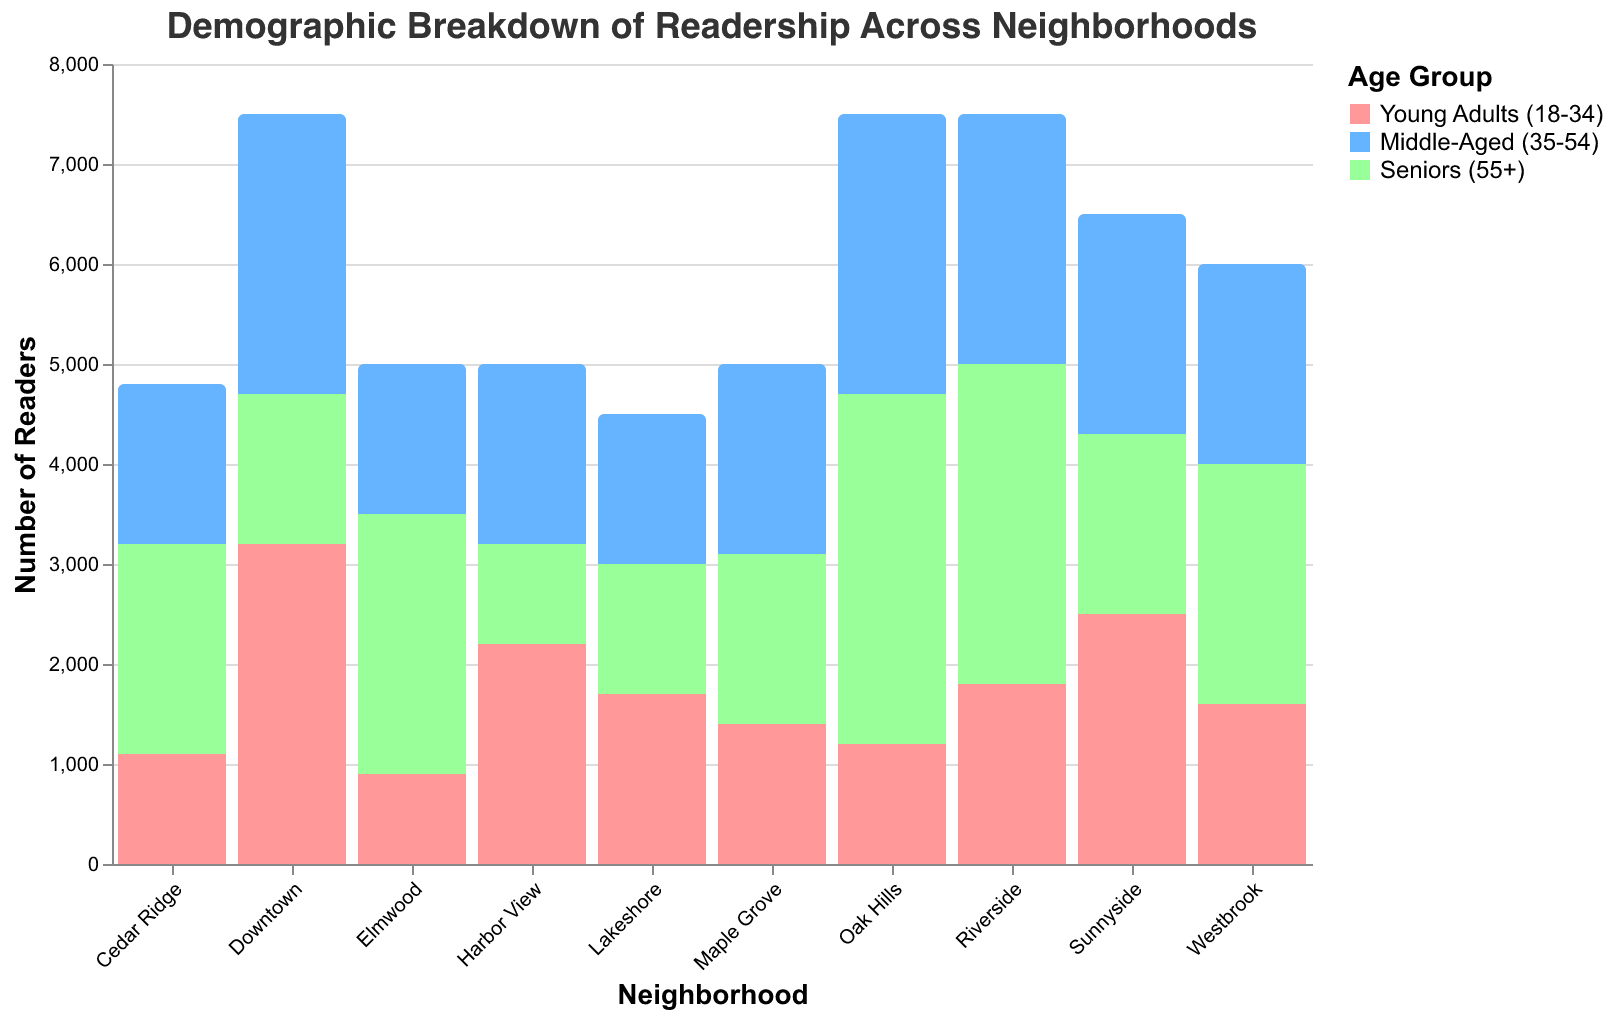Which neighborhood has the highest total readership? According to the figure, the neighborhood with the highest bar for total readership would indicate the highest number. Downtown has the tallest bar at 7500 readers.
Answer: Downtown Which age group has the most readers in Oak Hills? In Oak Hills, the age group with the highest bar in the corresponding section of the chart is Seniors (55+), with a value of 3500.
Answer: Seniors (55+) Compare the number of middle-aged readers (35-54) in Downtown and Riverside. Which neighborhood has more? By examining the respective bars for middle-aged readers (35-54) in Downtown and Riverside, we see that Downtown has 2800, while Riverside has 2500. Therefore, Downtown has more.
Answer: Downtown What is the total number of readers in Elmwood and Cedar Ridge combined? Adding the total readership values from Elmwood (5000) and Cedar Ridge (4800) gives 5000 + 4800 = 9800.
Answer: 9800 How does the number of young adult readers in Sunnyside compare to those in Westbrook? Comparing the bars for young adult readers, Sunnyside has a value of 2500, and Westbrook has 1600. Sunnyside has 900 more young adult readers than Westbrook (2500 - 1600 = 900).
Answer: Sunnyside has 900 more Which age group is least represented in Harbor View? The age group with the smallest bar in Harbor View is Seniors (55+), with a value of 1000.
Answer: Seniors (55+) What is the difference in the number of middle-aged readers between Maple Grove and Lakeshore? The value for middle-aged readers in Maple Grove is 1900, and in Lakeshore, it is 1500. The difference is 1900 - 1500 = 400.
Answer: 400 Is the total readership in Sunnyside greater than in Elmwood? Comparing the total readership bars, Sunnyside has 6500, while Elmwood has 5000. Therefore, the total readership in Sunnyside is greater.
Answer: Yes What’s the total number of readers across all neighborhoods for young adults (18-34)? Sum the number of young adult readers from all neighborhoods: 3200 (Downtown) + 1800 (Riverside) + 1200 (Oak Hills) + 2500 (Sunnyside) + 1600 (Westbrook) + 900 (Elmwood) + 2200 (Harbor View) + 1400 (Maple Grove) + 1100 (Cedar Ridge) + 1700 (Lakeshore) = 18600.
Answer: 18600 